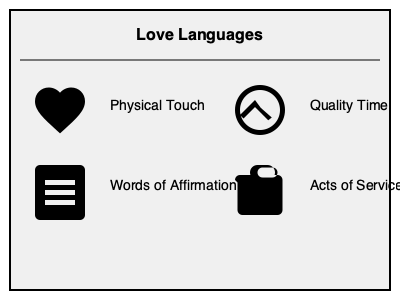Based on the illustrated love languages, which one is represented by the image of a heart and typically involves hugs, kisses, and holding hands? Let's analyze the love languages illustrated in the image:

1. In the top-left quadrant, we see a heart icon paired with the text "Physical Touch". This love language is represented by physical expressions of affection such as hugs, kisses, and holding hands.

2. In the bottom-left quadrant, there's a document or speech bubble icon with "Words of Affirmation". This relates to expressing love through verbal compliments and encouragement.

3. In the top-right quadrant, we see a clock icon with "Quality Time". This love language involves giving undivided attention and spending meaningful time together.

4. In the bottom-right quadrant, there's a gift box icon with "Acts of Service". This represents doing helpful things for your partner to express love.

Among these, the love language that is represented by a heart icon and involves physical expressions of affection like hugs, kisses, and holding hands is Physical Touch.
Answer: Physical Touch 